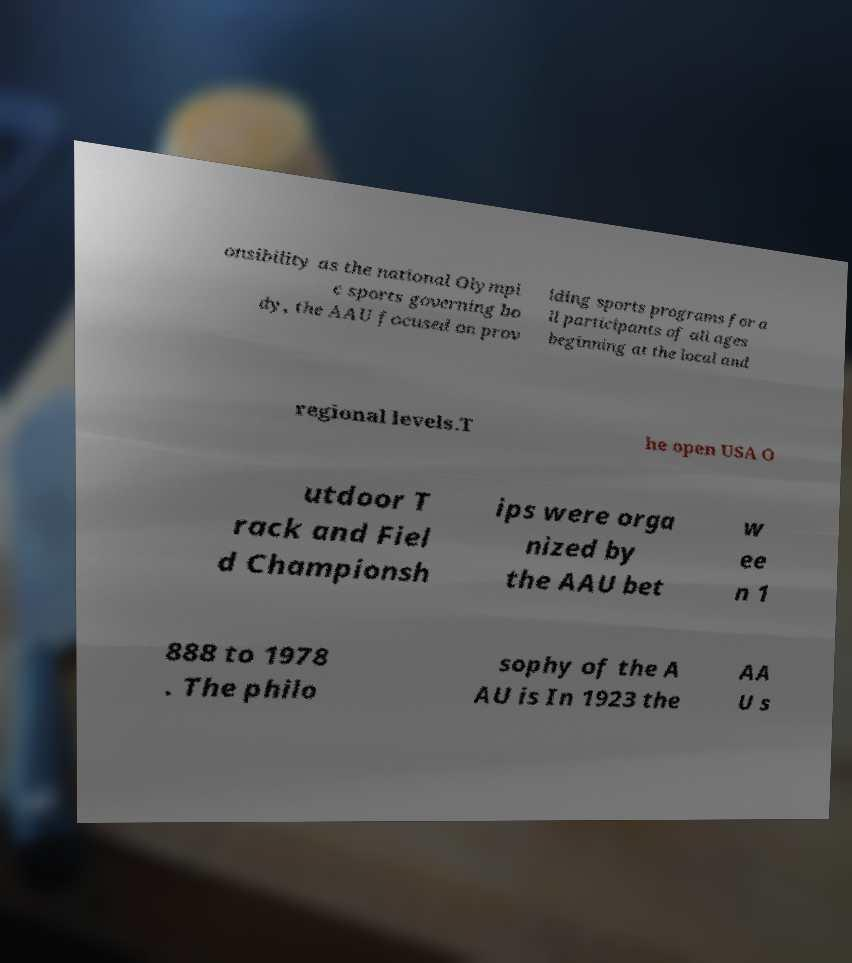Can you accurately transcribe the text from the provided image for me? onsibility as the national Olympi c sports governing bo dy, the AAU focused on prov iding sports programs for a ll participants of all ages beginning at the local and regional levels.T he open USA O utdoor T rack and Fiel d Championsh ips were orga nized by the AAU bet w ee n 1 888 to 1978 . The philo sophy of the A AU is In 1923 the AA U s 